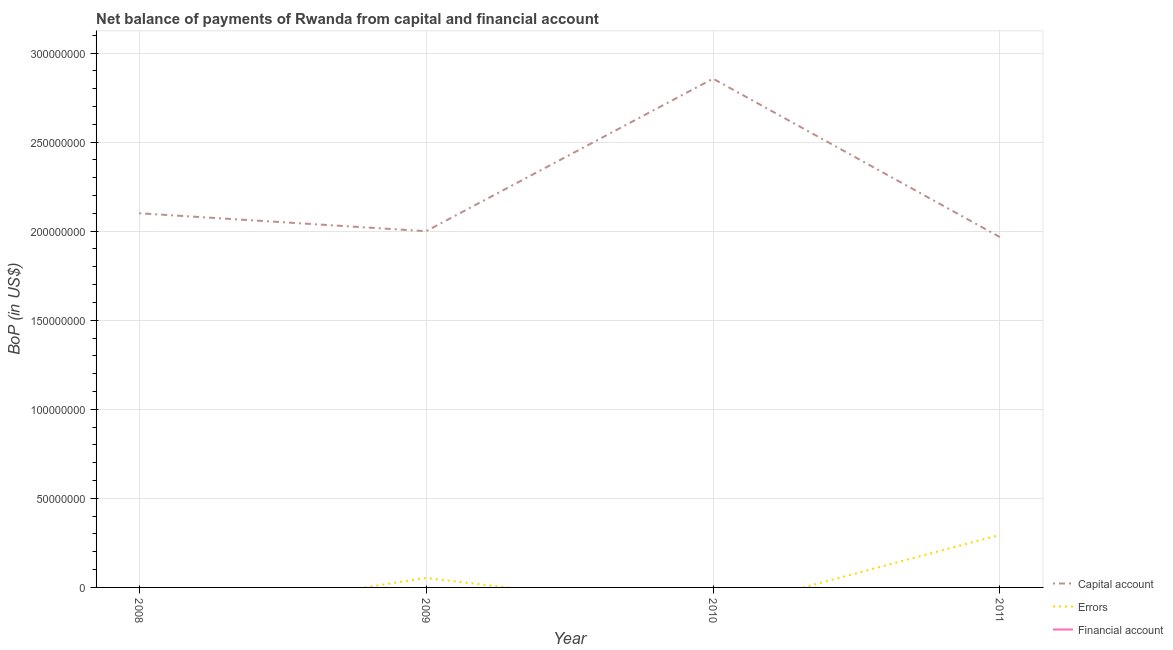How many different coloured lines are there?
Offer a terse response. 2. Across all years, what is the maximum amount of net capital account?
Give a very brief answer. 2.86e+08. In which year was the amount of errors maximum?
Your answer should be compact. 2011. What is the difference between the amount of net capital account in 2010 and that in 2011?
Make the answer very short. 8.90e+07. What is the difference between the amount of errors in 2010 and the amount of net capital account in 2008?
Provide a short and direct response. -2.10e+08. What is the average amount of errors per year?
Your answer should be very brief. 8.71e+06. In the year 2011, what is the difference between the amount of errors and amount of net capital account?
Keep it short and to the point. -1.67e+08. In how many years, is the amount of errors greater than 50000000 US$?
Your answer should be very brief. 0. What is the ratio of the amount of net capital account in 2008 to that in 2009?
Ensure brevity in your answer.  1.05. Is the amount of net capital account in 2009 less than that in 2010?
Offer a terse response. Yes. What is the difference between the highest and the second highest amount of net capital account?
Offer a very short reply. 7.56e+07. What is the difference between the highest and the lowest amount of errors?
Offer a terse response. 2.95e+07. In how many years, is the amount of financial account greater than the average amount of financial account taken over all years?
Offer a very short reply. 0. Is it the case that in every year, the sum of the amount of net capital account and amount of errors is greater than the amount of financial account?
Provide a short and direct response. Yes. Is the amount of financial account strictly greater than the amount of errors over the years?
Ensure brevity in your answer.  No. How many lines are there?
Offer a very short reply. 2. How many years are there in the graph?
Give a very brief answer. 4. Are the values on the major ticks of Y-axis written in scientific E-notation?
Give a very brief answer. No. Where does the legend appear in the graph?
Ensure brevity in your answer.  Bottom right. What is the title of the graph?
Ensure brevity in your answer.  Net balance of payments of Rwanda from capital and financial account. Does "Renewable sources" appear as one of the legend labels in the graph?
Offer a terse response. No. What is the label or title of the X-axis?
Offer a very short reply. Year. What is the label or title of the Y-axis?
Offer a terse response. BoP (in US$). What is the BoP (in US$) in Capital account in 2008?
Keep it short and to the point. 2.10e+08. What is the BoP (in US$) of Errors in 2008?
Your response must be concise. 0. What is the BoP (in US$) in Financial account in 2008?
Provide a succinct answer. 0. What is the BoP (in US$) of Capital account in 2009?
Offer a terse response. 2.00e+08. What is the BoP (in US$) in Errors in 2009?
Your response must be concise. 5.32e+06. What is the BoP (in US$) in Financial account in 2009?
Ensure brevity in your answer.  0. What is the BoP (in US$) in Capital account in 2010?
Provide a short and direct response. 2.86e+08. What is the BoP (in US$) of Capital account in 2011?
Your response must be concise. 1.97e+08. What is the BoP (in US$) of Errors in 2011?
Your answer should be compact. 2.95e+07. Across all years, what is the maximum BoP (in US$) in Capital account?
Your answer should be very brief. 2.86e+08. Across all years, what is the maximum BoP (in US$) in Errors?
Provide a succinct answer. 2.95e+07. Across all years, what is the minimum BoP (in US$) of Capital account?
Offer a very short reply. 1.97e+08. What is the total BoP (in US$) in Capital account in the graph?
Offer a very short reply. 8.92e+08. What is the total BoP (in US$) in Errors in the graph?
Keep it short and to the point. 3.49e+07. What is the total BoP (in US$) of Financial account in the graph?
Your response must be concise. 0. What is the difference between the BoP (in US$) in Capital account in 2008 and that in 2009?
Your answer should be very brief. 1.01e+07. What is the difference between the BoP (in US$) of Capital account in 2008 and that in 2010?
Ensure brevity in your answer.  -7.56e+07. What is the difference between the BoP (in US$) of Capital account in 2008 and that in 2011?
Keep it short and to the point. 1.34e+07. What is the difference between the BoP (in US$) of Capital account in 2009 and that in 2010?
Make the answer very short. -8.56e+07. What is the difference between the BoP (in US$) in Capital account in 2009 and that in 2011?
Give a very brief answer. 3.34e+06. What is the difference between the BoP (in US$) of Errors in 2009 and that in 2011?
Give a very brief answer. -2.42e+07. What is the difference between the BoP (in US$) in Capital account in 2010 and that in 2011?
Ensure brevity in your answer.  8.90e+07. What is the difference between the BoP (in US$) of Capital account in 2008 and the BoP (in US$) of Errors in 2009?
Ensure brevity in your answer.  2.05e+08. What is the difference between the BoP (in US$) of Capital account in 2008 and the BoP (in US$) of Errors in 2011?
Offer a terse response. 1.81e+08. What is the difference between the BoP (in US$) of Capital account in 2009 and the BoP (in US$) of Errors in 2011?
Provide a short and direct response. 1.70e+08. What is the difference between the BoP (in US$) in Capital account in 2010 and the BoP (in US$) in Errors in 2011?
Provide a succinct answer. 2.56e+08. What is the average BoP (in US$) of Capital account per year?
Ensure brevity in your answer.  2.23e+08. What is the average BoP (in US$) of Errors per year?
Provide a succinct answer. 8.71e+06. In the year 2009, what is the difference between the BoP (in US$) in Capital account and BoP (in US$) in Errors?
Offer a very short reply. 1.95e+08. In the year 2011, what is the difference between the BoP (in US$) of Capital account and BoP (in US$) of Errors?
Your response must be concise. 1.67e+08. What is the ratio of the BoP (in US$) of Capital account in 2008 to that in 2009?
Ensure brevity in your answer.  1.05. What is the ratio of the BoP (in US$) in Capital account in 2008 to that in 2010?
Provide a short and direct response. 0.74. What is the ratio of the BoP (in US$) of Capital account in 2008 to that in 2011?
Ensure brevity in your answer.  1.07. What is the ratio of the BoP (in US$) of Capital account in 2009 to that in 2010?
Make the answer very short. 0.7. What is the ratio of the BoP (in US$) in Capital account in 2009 to that in 2011?
Offer a very short reply. 1.02. What is the ratio of the BoP (in US$) in Errors in 2009 to that in 2011?
Offer a very short reply. 0.18. What is the ratio of the BoP (in US$) in Capital account in 2010 to that in 2011?
Provide a short and direct response. 1.45. What is the difference between the highest and the second highest BoP (in US$) of Capital account?
Keep it short and to the point. 7.56e+07. What is the difference between the highest and the lowest BoP (in US$) in Capital account?
Provide a short and direct response. 8.90e+07. What is the difference between the highest and the lowest BoP (in US$) in Errors?
Provide a succinct answer. 2.95e+07. 